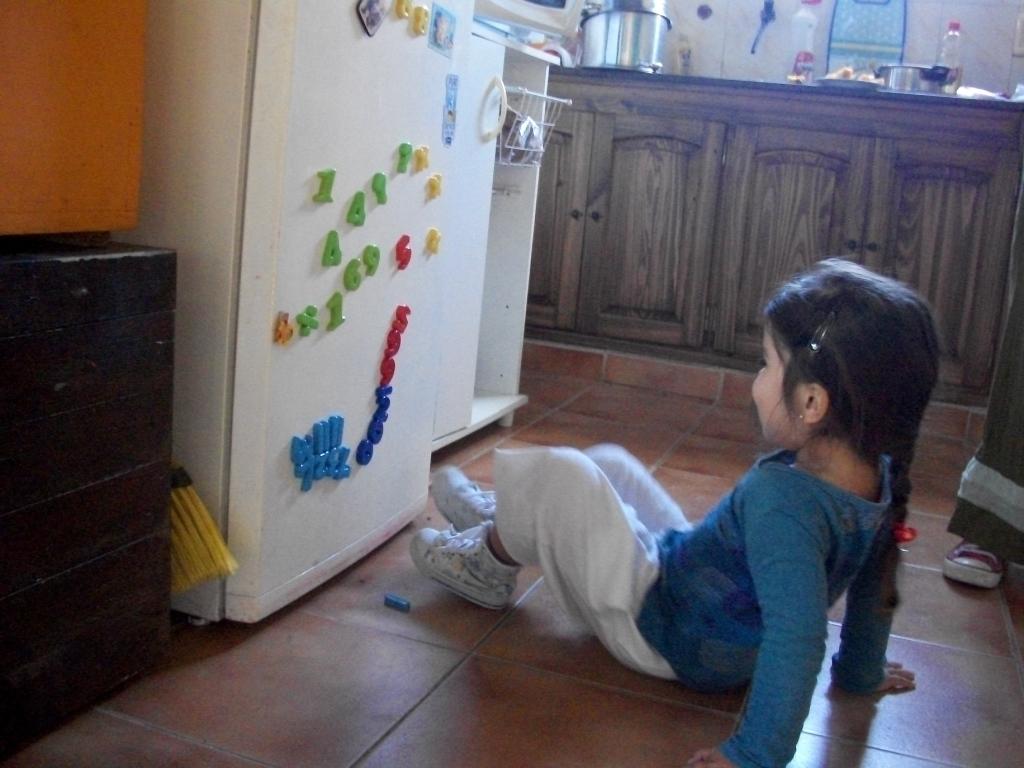What number is the red one to the right of the green 9?
Offer a very short reply. 5. 